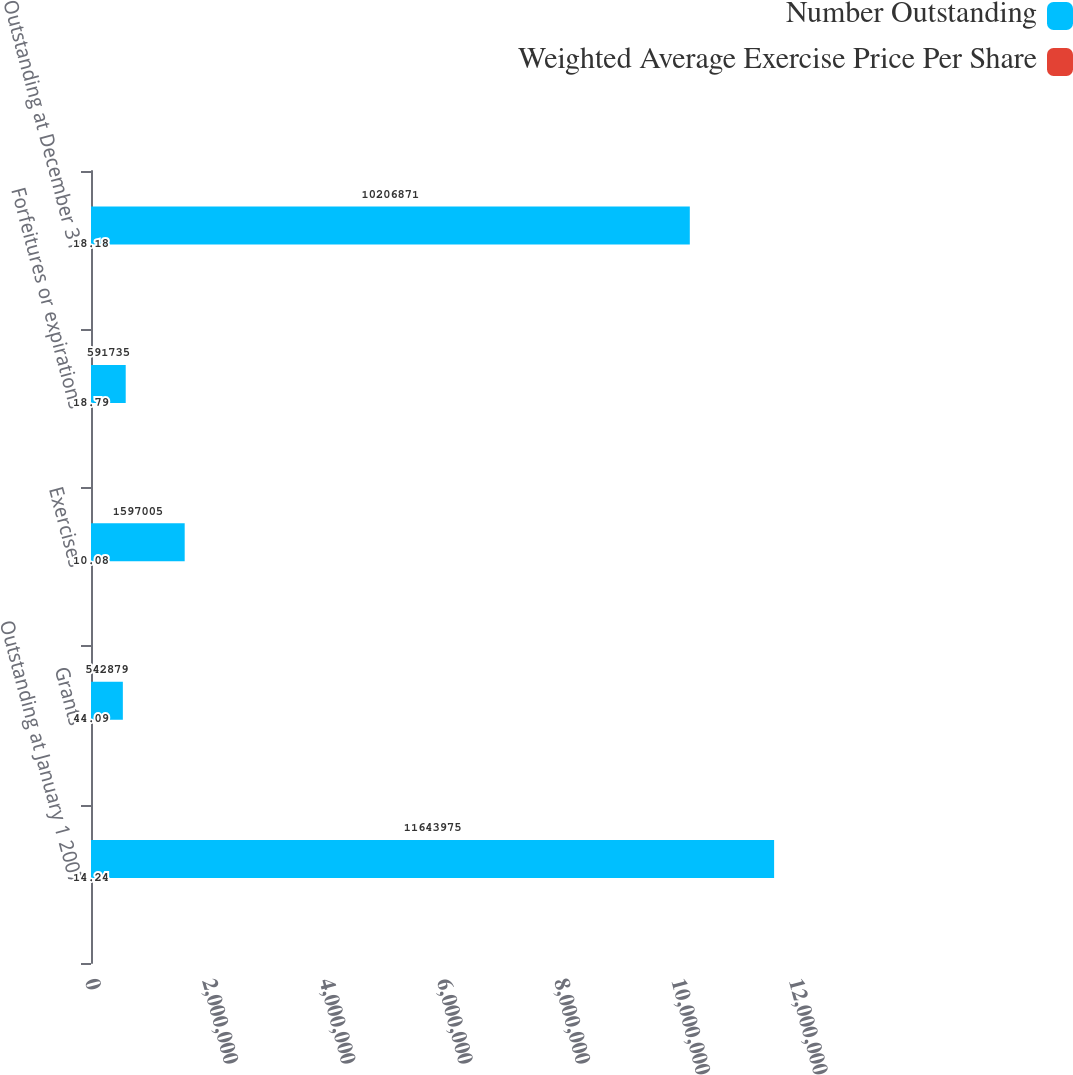Convert chart to OTSL. <chart><loc_0><loc_0><loc_500><loc_500><stacked_bar_chart><ecel><fcel>Outstanding at January 1 2007<fcel>Grants<fcel>Exercises<fcel>Forfeitures or expirations<fcel>Outstanding at December 31<nl><fcel>Number Outstanding<fcel>1.1644e+07<fcel>542879<fcel>1.597e+06<fcel>591735<fcel>1.02069e+07<nl><fcel>Weighted Average Exercise Price Per Share<fcel>14.24<fcel>44.09<fcel>10.08<fcel>18.79<fcel>18.18<nl></chart> 